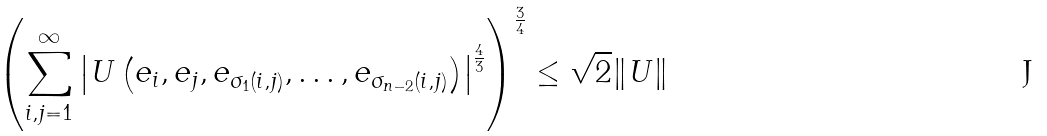<formula> <loc_0><loc_0><loc_500><loc_500>\left ( \sum _ { i , j = 1 } ^ { \infty } \left | U \left ( e _ { i } , e _ { j } , e _ { \sigma _ { 1 } ( i , j ) } , \dots , e _ { \sigma _ { n - 2 } ( i , j ) } \right ) \right | ^ { \frac { 4 } { 3 } } \right ) ^ { \frac { 3 } { 4 } } \leq \sqrt { 2 } \| U \|</formula> 